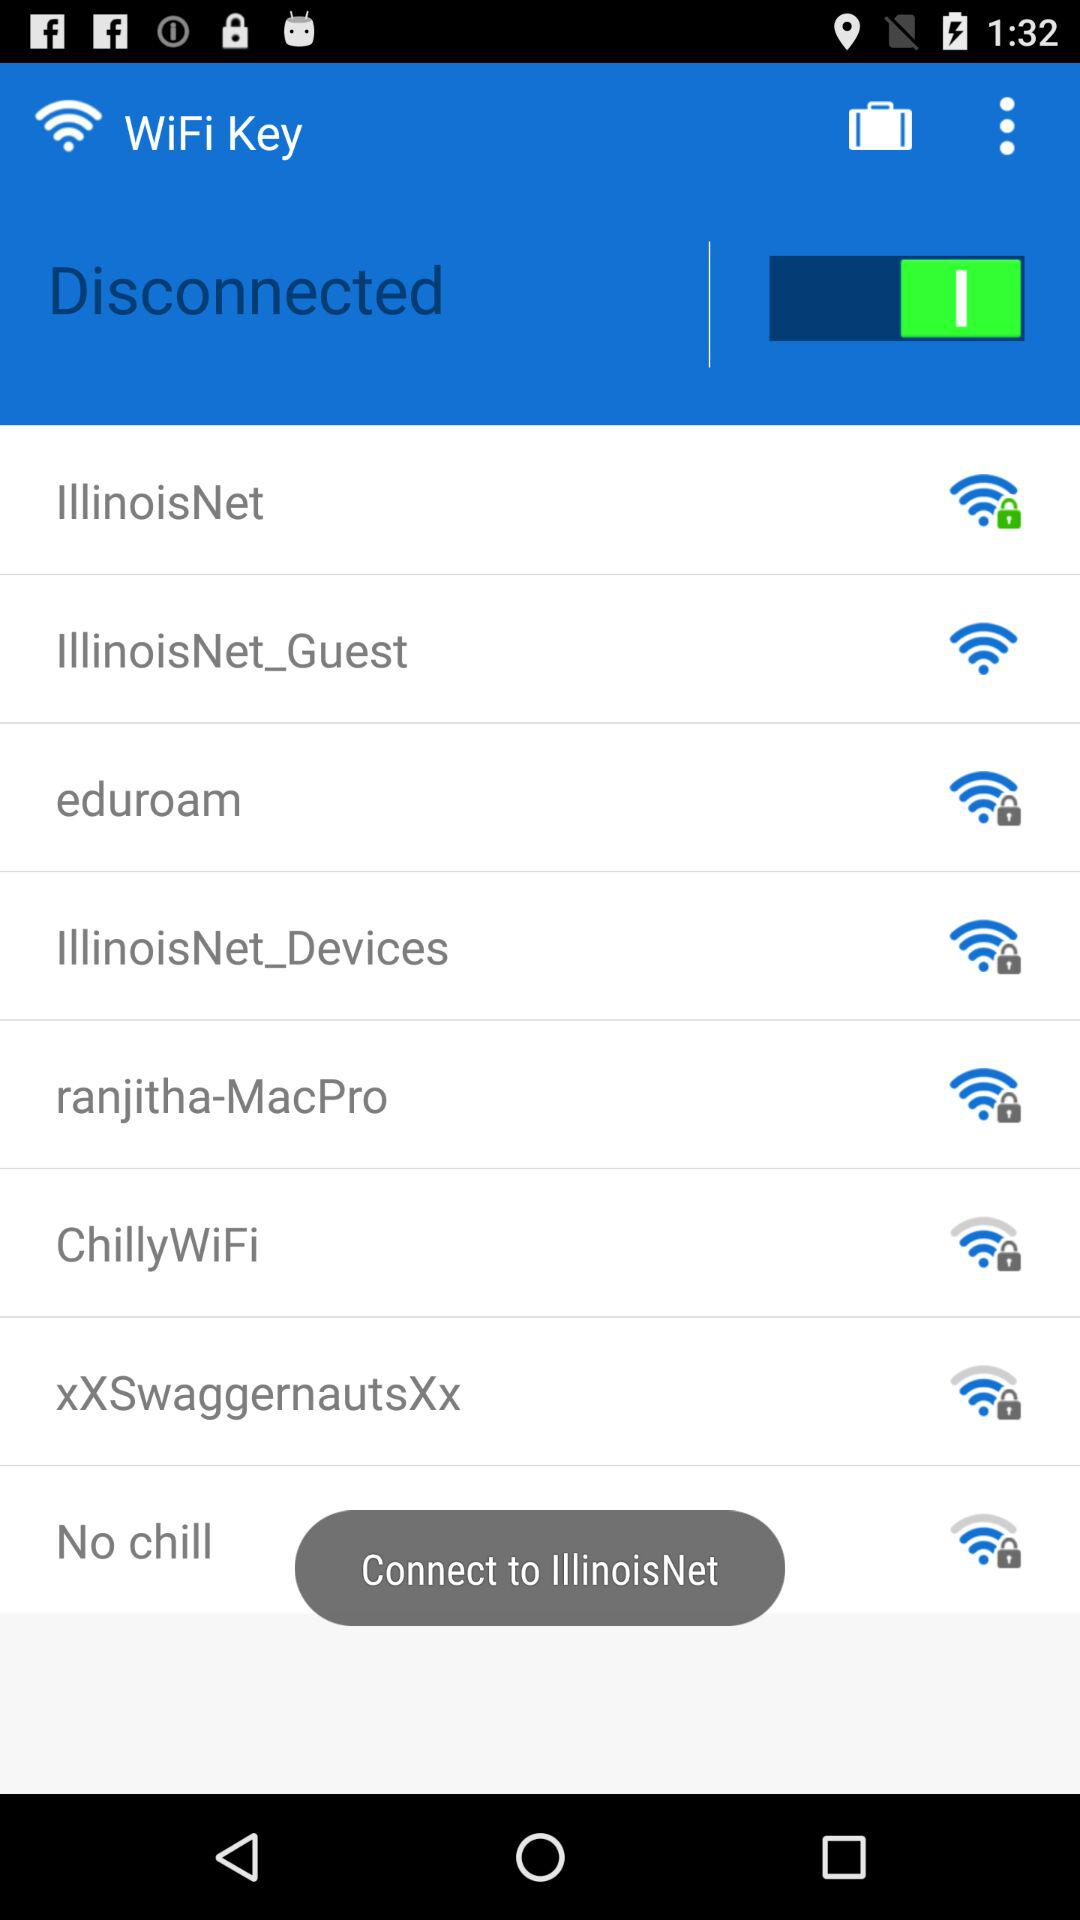What are the options available for WiFi? The options available for WiFi is "Illinois Net", "IllinoisNet_Guest", "eduroam", "IllinoisNet Devices", "ranjitha-MacPro", "ChillyWiFi", "XXSwaggernautsXx" and "No chill". 